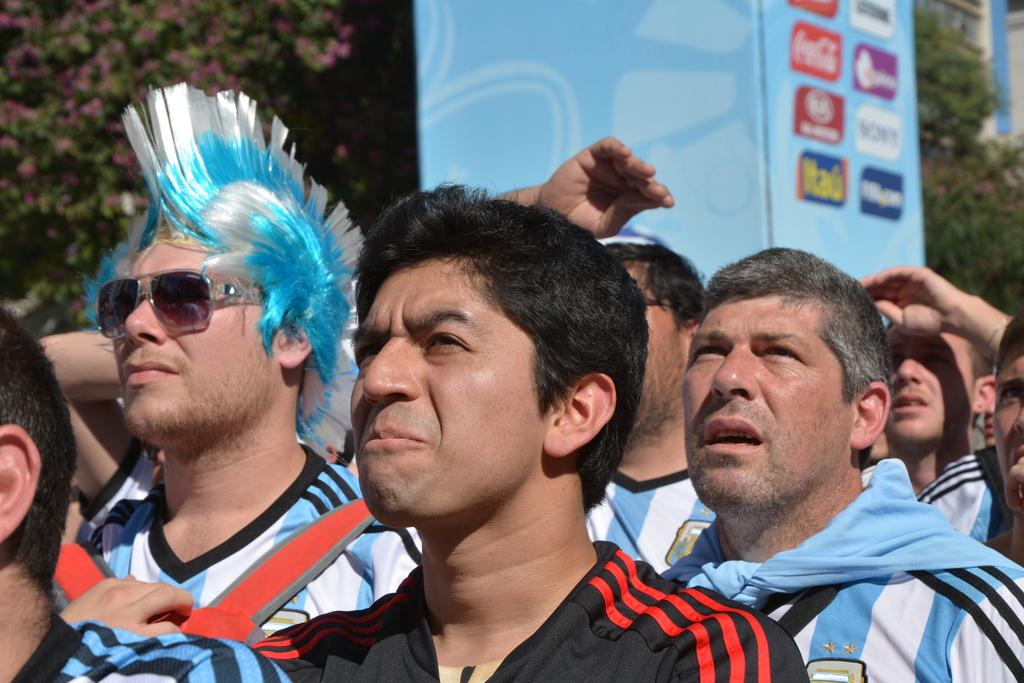What can be seen in the image involving people? There are people standing in the image. What is written or displayed on the board in the image? There is a board with text in the image. What type of natural environment is visible in the image? There are trees visible in the image. What type of structure can be seen in the background of the image? There is a building in the background of the image. Can you describe the appearance of one of the people in the image? A man is wearing spectacles in the image. Can you tell me how many chickens are visible in the image? There are no chickens present in the image. What type of snake is wrapped around the man's neck in the image? There is no snake present in the image; a man is wearing spectacles. 